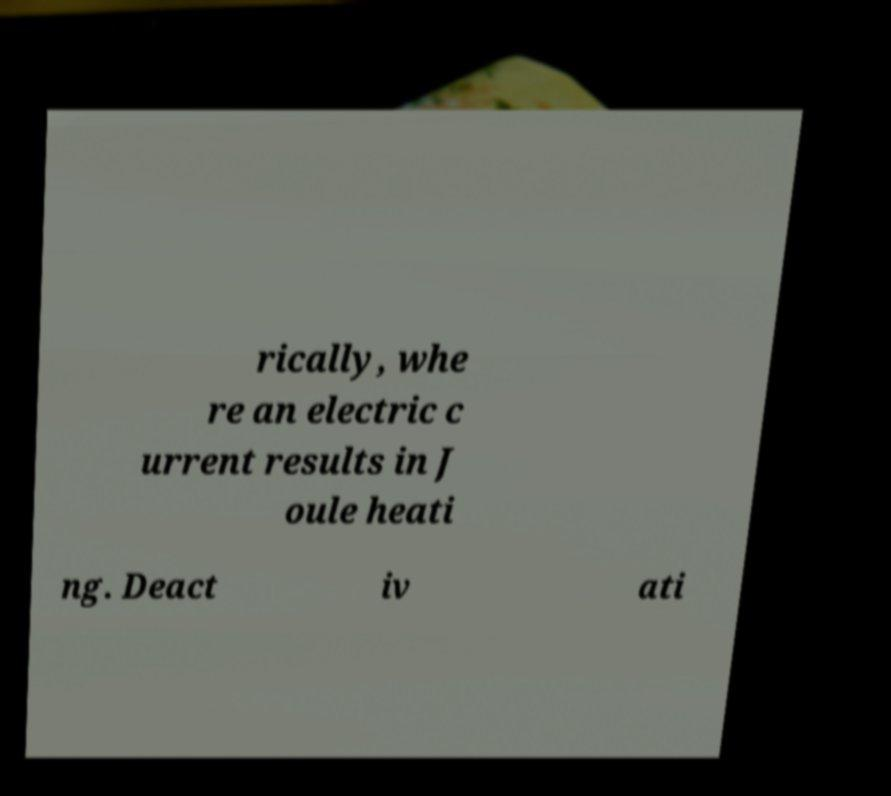I need the written content from this picture converted into text. Can you do that? rically, whe re an electric c urrent results in J oule heati ng. Deact iv ati 